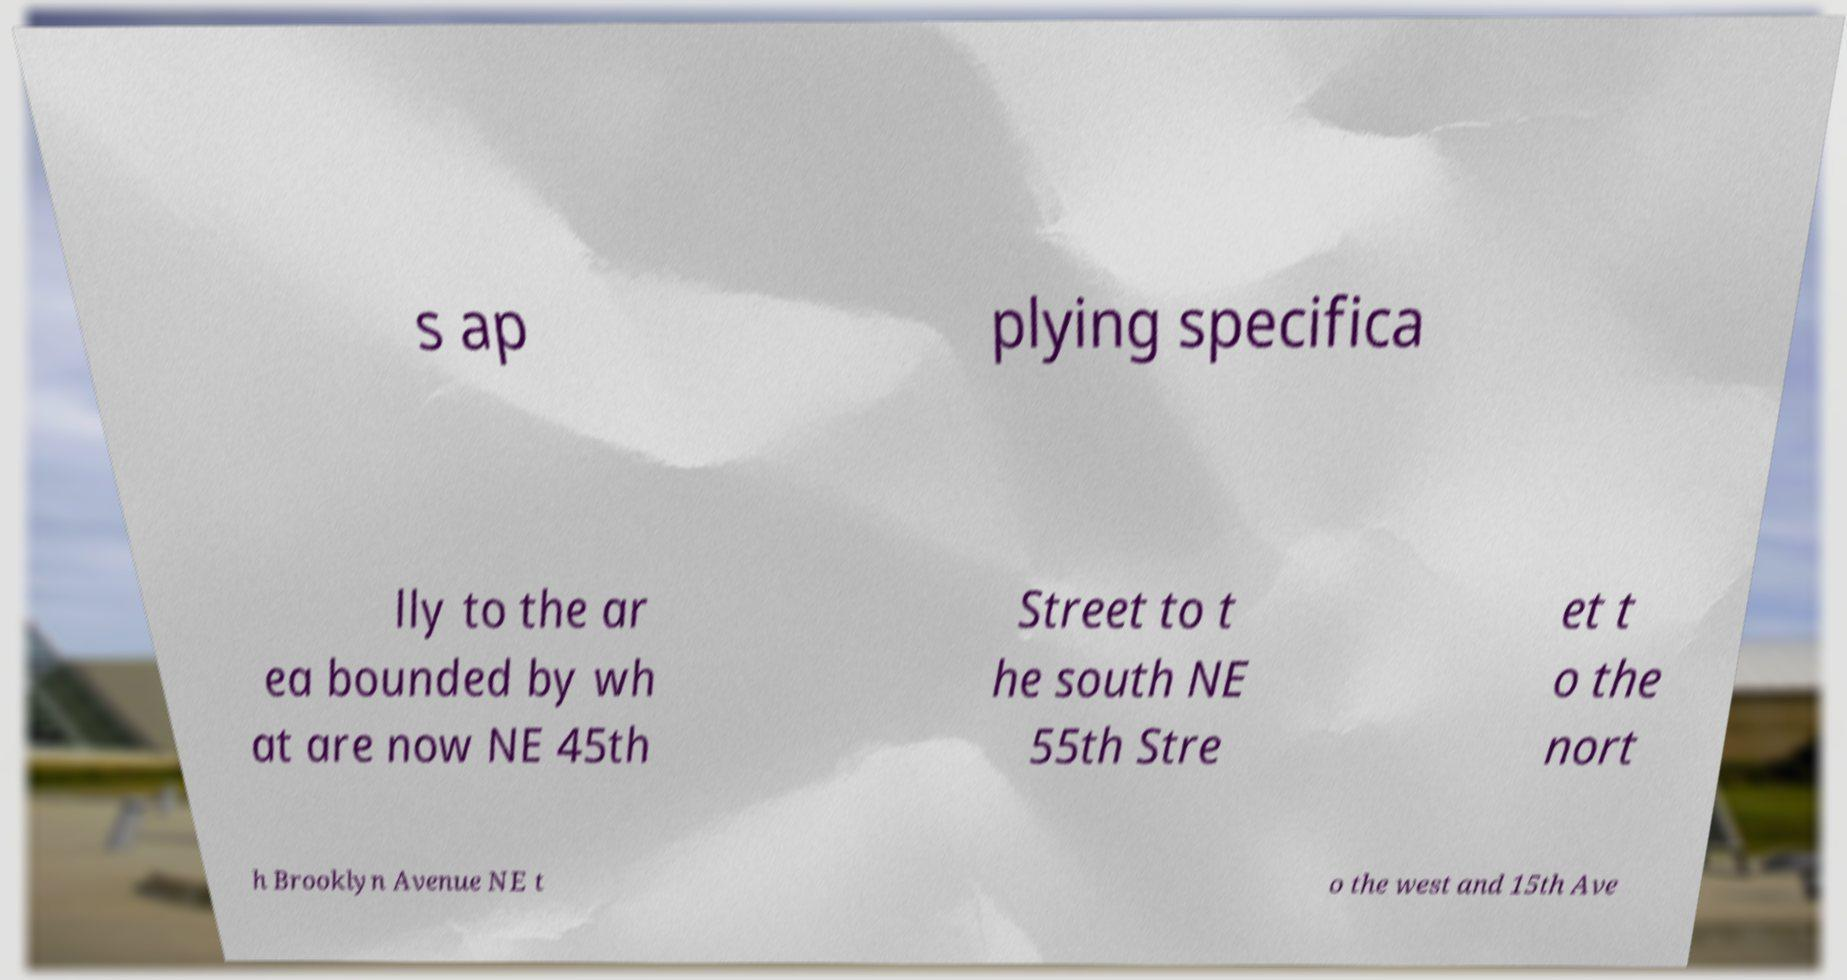For documentation purposes, I need the text within this image transcribed. Could you provide that? s ap plying specifica lly to the ar ea bounded by wh at are now NE 45th Street to t he south NE 55th Stre et t o the nort h Brooklyn Avenue NE t o the west and 15th Ave 